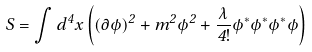<formula> <loc_0><loc_0><loc_500><loc_500>S = \int { d ^ { 4 } x \left ( ( \partial \phi ) ^ { 2 } + m ^ { 2 } \phi ^ { 2 } + \frac { \lambda } { 4 ! } \phi ^ { * } \phi ^ { * } \phi ^ { * } \phi \right ) }</formula> 